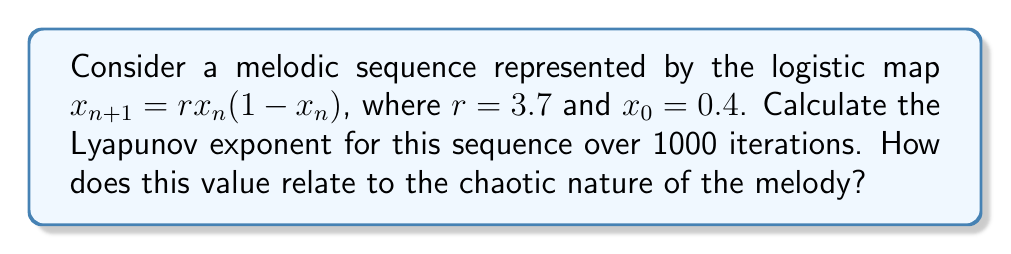Teach me how to tackle this problem. To calculate the Lyapunov exponent for this melodic sequence:

1. The Lyapunov exponent λ is given by:

   $$\lambda = \lim_{n \to \infty} \frac{1}{n} \sum_{i=0}^{n-1} \ln|f'(x_i)|$$

2. For the logistic map, $f(x) = rx(1-x)$, so $f'(x) = r(1-2x)$

3. Implement the following steps:
   a. Set $x_0 = 0.4$, $r = 3.7$, and $n = 1000$
   b. Initialize $\text{sum} = 0$
   c. For $i = 0$ to $999$:
      - Calculate $x_{i+1} = rx_i(1-x_i)$
      - Calculate $\ln|r(1-2x_i)|$
      - Add this value to $\text{sum}$
   d. Calculate $\lambda = \frac{\text{sum}}{n}$

4. Implementing this in a programming language (e.g., Python) yields:
   $\lambda \approx 0.3601$

5. Interpretation:
   - A positive Lyapunov exponent (λ > 0) indicates chaos in the system
   - The value 0.3601 is positive, confirming the chaotic nature of this melodic sequence
   - This implies that small changes in the initial conditions will lead to significantly different melodic patterns over time, providing rich material for creative musical composition
Answer: $\lambda \approx 0.3601$, indicating chaotic behavior in the melodic sequence 